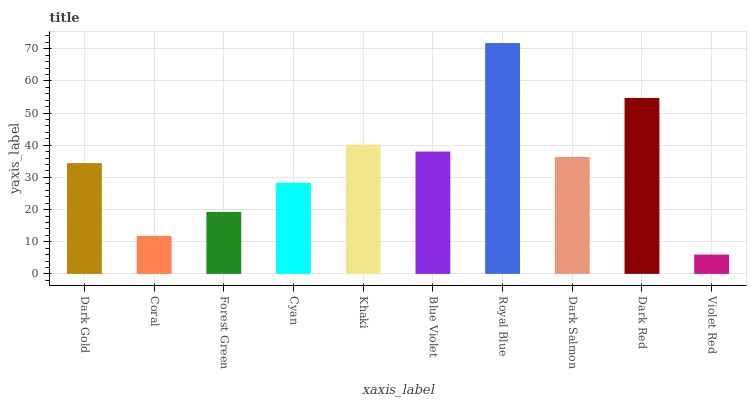Is Violet Red the minimum?
Answer yes or no. Yes. Is Royal Blue the maximum?
Answer yes or no. Yes. Is Coral the minimum?
Answer yes or no. No. Is Coral the maximum?
Answer yes or no. No. Is Dark Gold greater than Coral?
Answer yes or no. Yes. Is Coral less than Dark Gold?
Answer yes or no. Yes. Is Coral greater than Dark Gold?
Answer yes or no. No. Is Dark Gold less than Coral?
Answer yes or no. No. Is Dark Salmon the high median?
Answer yes or no. Yes. Is Dark Gold the low median?
Answer yes or no. Yes. Is Royal Blue the high median?
Answer yes or no. No. Is Dark Red the low median?
Answer yes or no. No. 